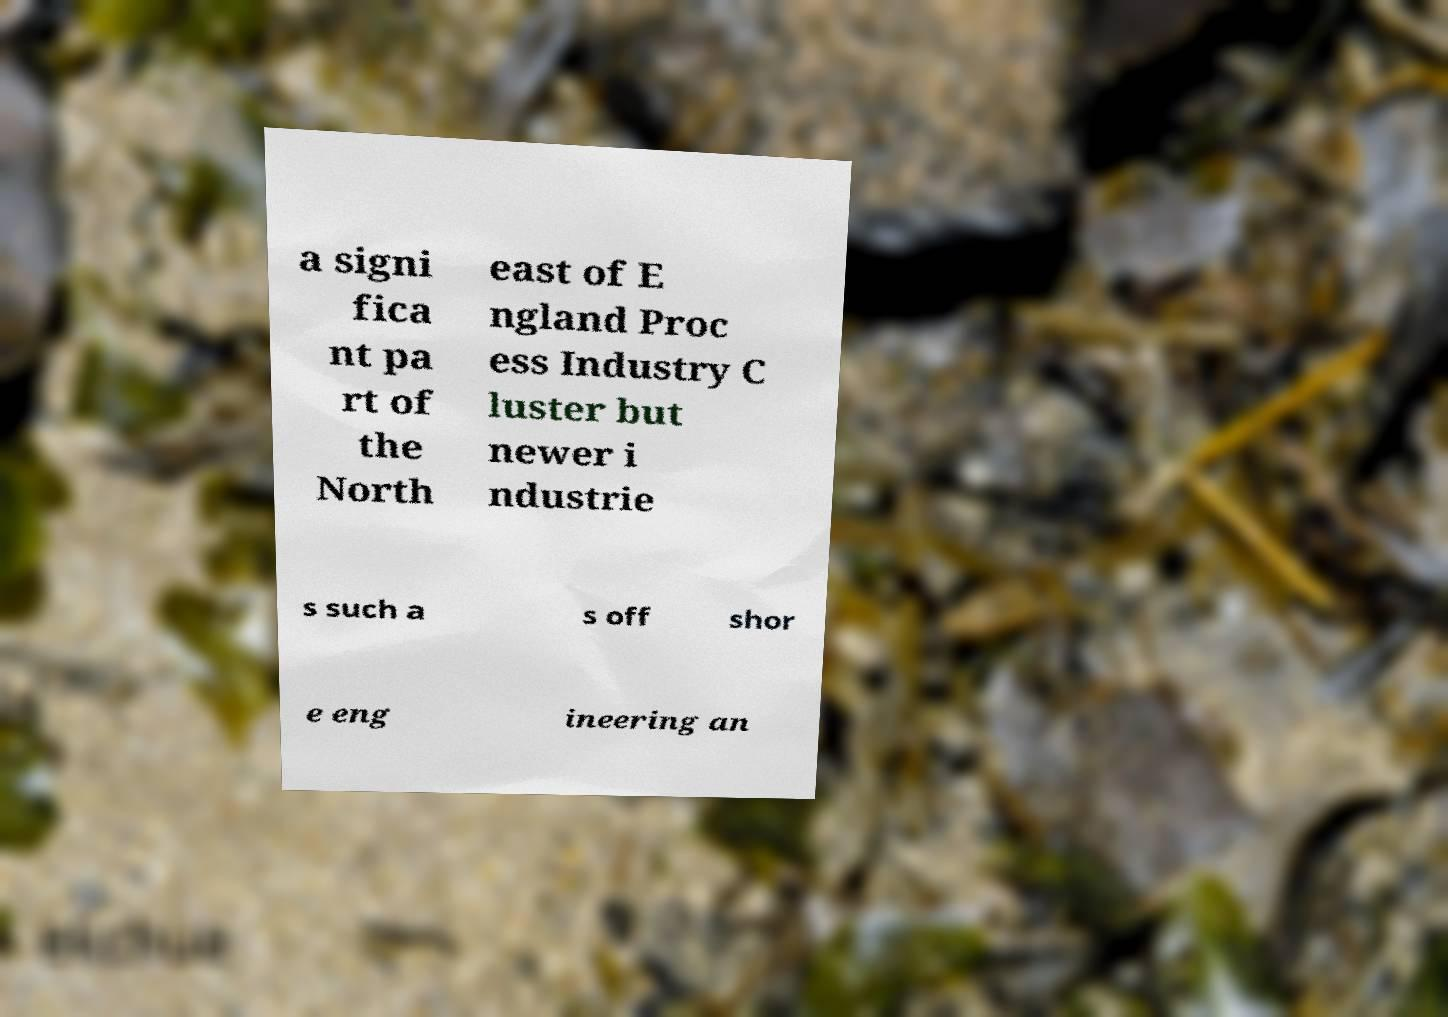What messages or text are displayed in this image? I need them in a readable, typed format. a signi fica nt pa rt of the North east of E ngland Proc ess Industry C luster but newer i ndustrie s such a s off shor e eng ineering an 